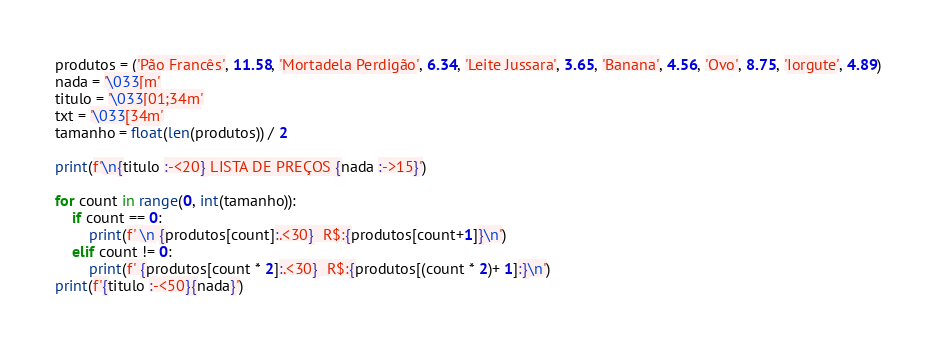<code> <loc_0><loc_0><loc_500><loc_500><_Python_>produtos = ('Pão Francês', 11.58, 'Mortadela Perdigão', 6.34, 'Leite Jussara', 3.65, 'Banana', 4.56, 'Ovo', 8.75, 'Iorgute', 4.89)
nada = '\033[m'
titulo = '\033[01;34m'
txt = '\033[34m'
tamanho = float(len(produtos)) / 2

print(f'\n{titulo :-<20} LISTA DE PREÇOS {nada :->15}')

for count in range(0, int(tamanho)):
    if count == 0:
        print(f' \n {produtos[count]:.<30}  R$:{produtos[count+1]}\n')
    elif count != 0:
        print(f' {produtos[count * 2]:.<30}  R$:{produtos[(count * 2)+ 1]:}\n')
print(f'{titulo :-<50}{nada}')</code> 